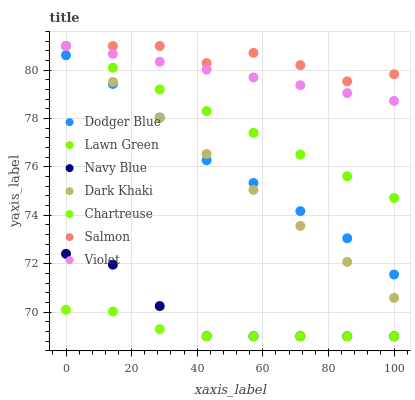Does Chartreuse have the minimum area under the curve?
Answer yes or no. Yes. Does Salmon have the maximum area under the curve?
Answer yes or no. Yes. Does Navy Blue have the minimum area under the curve?
Answer yes or no. No. Does Navy Blue have the maximum area under the curve?
Answer yes or no. No. Is Dark Khaki the smoothest?
Answer yes or no. Yes. Is Salmon the roughest?
Answer yes or no. Yes. Is Navy Blue the smoothest?
Answer yes or no. No. Is Navy Blue the roughest?
Answer yes or no. No. Does Navy Blue have the lowest value?
Answer yes or no. Yes. Does Salmon have the lowest value?
Answer yes or no. No. Does Violet have the highest value?
Answer yes or no. Yes. Does Navy Blue have the highest value?
Answer yes or no. No. Is Chartreuse less than Violet?
Answer yes or no. Yes. Is Salmon greater than Dodger Blue?
Answer yes or no. Yes. Does Dark Khaki intersect Violet?
Answer yes or no. Yes. Is Dark Khaki less than Violet?
Answer yes or no. No. Is Dark Khaki greater than Violet?
Answer yes or no. No. Does Chartreuse intersect Violet?
Answer yes or no. No. 